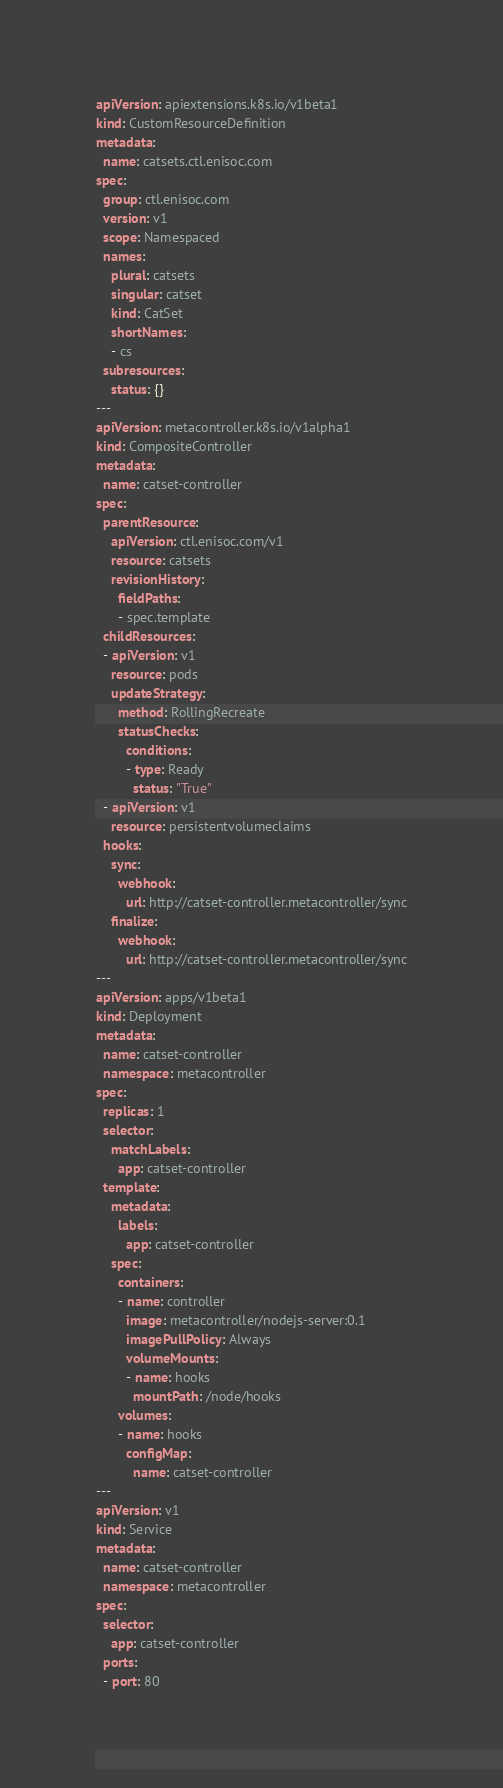Convert code to text. <code><loc_0><loc_0><loc_500><loc_500><_YAML_>apiVersion: apiextensions.k8s.io/v1beta1
kind: CustomResourceDefinition
metadata:
  name: catsets.ctl.enisoc.com
spec:
  group: ctl.enisoc.com
  version: v1
  scope: Namespaced
  names:
    plural: catsets
    singular: catset
    kind: CatSet
    shortNames:
    - cs
  subresources:
    status: {}
---
apiVersion: metacontroller.k8s.io/v1alpha1
kind: CompositeController
metadata:
  name: catset-controller
spec:
  parentResource:
    apiVersion: ctl.enisoc.com/v1
    resource: catsets
    revisionHistory:
      fieldPaths:
      - spec.template
  childResources:
  - apiVersion: v1
    resource: pods
    updateStrategy:
      method: RollingRecreate
      statusChecks:
        conditions:
        - type: Ready
          status: "True"
  - apiVersion: v1
    resource: persistentvolumeclaims
  hooks:
    sync:
      webhook:
        url: http://catset-controller.metacontroller/sync
    finalize:
      webhook:
        url: http://catset-controller.metacontroller/sync
---
apiVersion: apps/v1beta1
kind: Deployment
metadata:
  name: catset-controller
  namespace: metacontroller
spec:
  replicas: 1
  selector:
    matchLabels:
      app: catset-controller
  template:
    metadata:
      labels:
        app: catset-controller
    spec:
      containers:
      - name: controller
        image: metacontroller/nodejs-server:0.1
        imagePullPolicy: Always
        volumeMounts:
        - name: hooks
          mountPath: /node/hooks
      volumes:
      - name: hooks
        configMap:
          name: catset-controller
---
apiVersion: v1
kind: Service
metadata:
  name: catset-controller
  namespace: metacontroller
spec:
  selector:
    app: catset-controller
  ports:
  - port: 80
</code> 